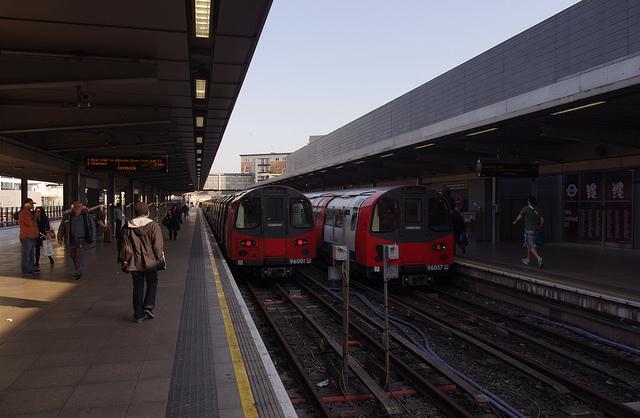How many trains are there?
Answer briefly. 2. What color vehicle is parked in the background on the right?
Quick response, please. Red. How many people are boarding the train?
Quick response, please. 0. How many trains are here?
Short answer required. 2. What stop number is listed on the sign?
Be succinct. 4. How many people are waiting for the train?
Be succinct. 10. Are there many people waiting for the train?
Give a very brief answer. No. Does this look like a train station in the US?
Be succinct. No. What are the people waiting for?
Write a very short answer. Train. How many tracks are there?
Short answer required. 2. Are the lights on in the train?
Short answer required. Yes. Can you board the train from this side?
Write a very short answer. Yes. Is this a busy train station?
Write a very short answer. Yes. Is this an old train?
Give a very brief answer. No. Are there people in the image?
Concise answer only. Yes. Is the sky clear?
Be succinct. Yes. What color is the train?
Concise answer only. Red. 